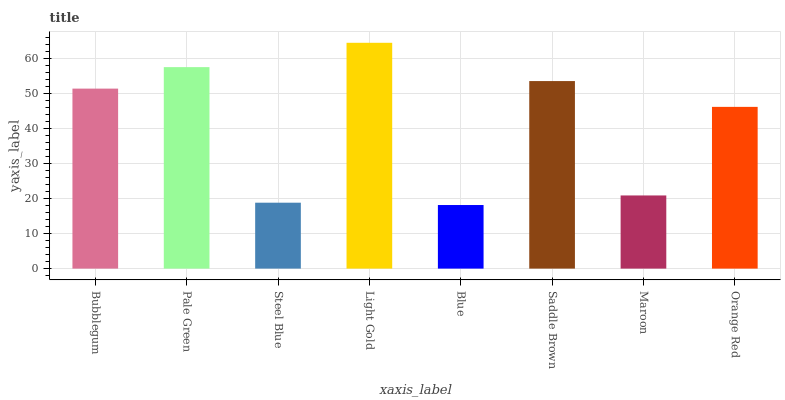Is Blue the minimum?
Answer yes or no. Yes. Is Light Gold the maximum?
Answer yes or no. Yes. Is Pale Green the minimum?
Answer yes or no. No. Is Pale Green the maximum?
Answer yes or no. No. Is Pale Green greater than Bubblegum?
Answer yes or no. Yes. Is Bubblegum less than Pale Green?
Answer yes or no. Yes. Is Bubblegum greater than Pale Green?
Answer yes or no. No. Is Pale Green less than Bubblegum?
Answer yes or no. No. Is Bubblegum the high median?
Answer yes or no. Yes. Is Orange Red the low median?
Answer yes or no. Yes. Is Maroon the high median?
Answer yes or no. No. Is Pale Green the low median?
Answer yes or no. No. 